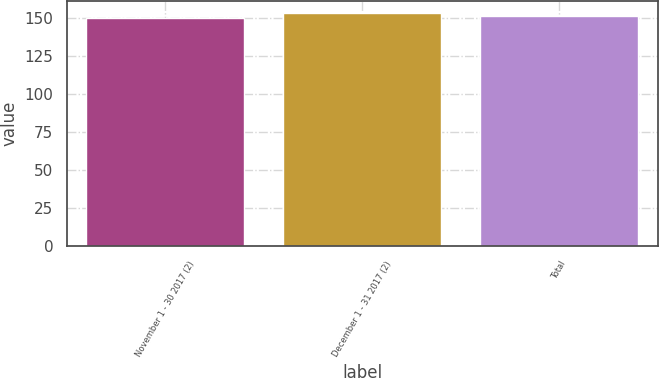Convert chart. <chart><loc_0><loc_0><loc_500><loc_500><bar_chart><fcel>November 1 - 30 2017 (2)<fcel>December 1 - 31 2017 (2)<fcel>Total<nl><fcel>150.4<fcel>153.42<fcel>151.61<nl></chart> 